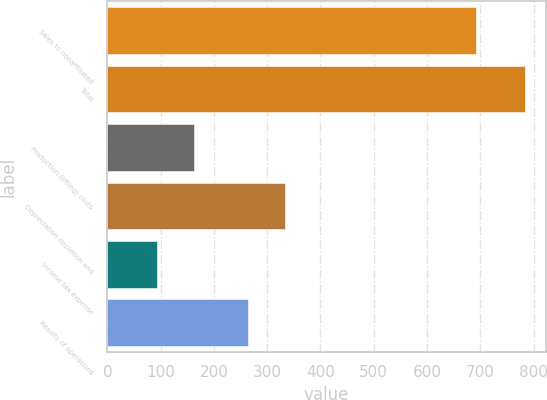Convert chart to OTSL. <chart><loc_0><loc_0><loc_500><loc_500><bar_chart><fcel>Sales to nonaffiliated<fcel>Total<fcel>Production (lifting) costs<fcel>Depreciation depletion and<fcel>Income tax expense<fcel>Results of operations<nl><fcel>691<fcel>784<fcel>162.1<fcel>333.1<fcel>93<fcel>264<nl></chart> 